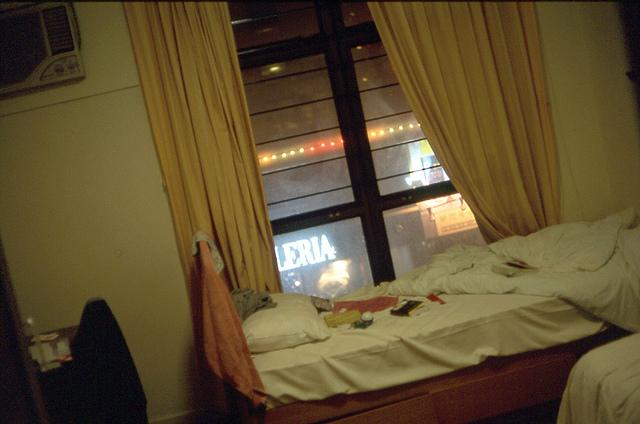The last four letters seen in the background are all found in what word? Please explain your reasoning. pizzeria. The letters seen in the background are found in pizzeria. 